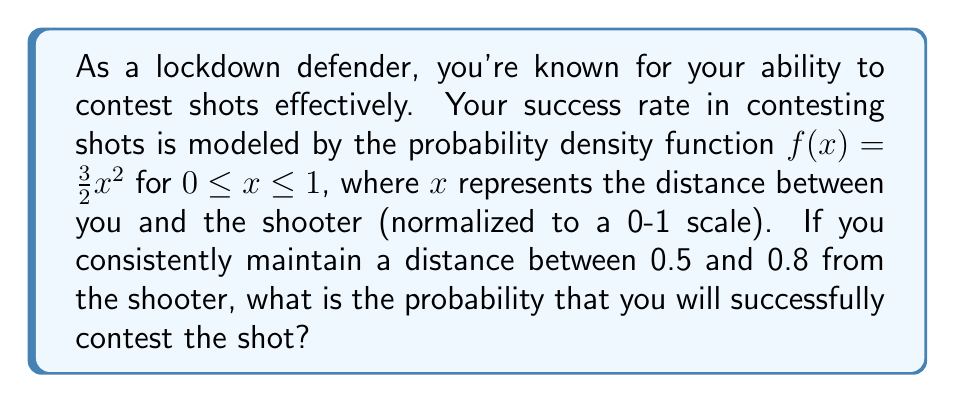Teach me how to tackle this problem. To solve this problem, we need to integrate the probability density function over the given interval. Here's the step-by-step solution:

1) The probability of successfully contesting the shot is given by the integral of $f(x)$ from 0.5 to 0.8:

   $$P(0.5 \leq x \leq 0.8) = \int_{0.5}^{0.8} f(x) dx = \int_{0.5}^{0.8} \frac{3}{2}x^2 dx$$

2) Integrate the function:

   $$\int_{0.5}^{0.8} \frac{3}{2}x^2 dx = \frac{3}{2} \int_{0.5}^{0.8} x^2 dx = \frac{3}{2} \cdot \frac{x^3}{3} \Big|_{0.5}^{0.8}$$

3) Evaluate the integral:

   $$\frac{3}{2} \cdot \frac{x^3}{3} \Big|_{0.5}^{0.8} = \frac{1}{2}x^3 \Big|_{0.5}^{0.8} = \frac{1}{2}(0.8^3 - 0.5^3)$$

4) Calculate the final result:

   $$\frac{1}{2}(0.8^3 - 0.5^3) = \frac{1}{2}(0.512 - 0.125) = \frac{1}{2}(0.387) = 0.1935$$

Therefore, the probability of successfully contesting the shot when maintaining a distance between 0.5 and 0.8 from the shooter is approximately 0.1935 or 19.35%.
Answer: 0.1935 